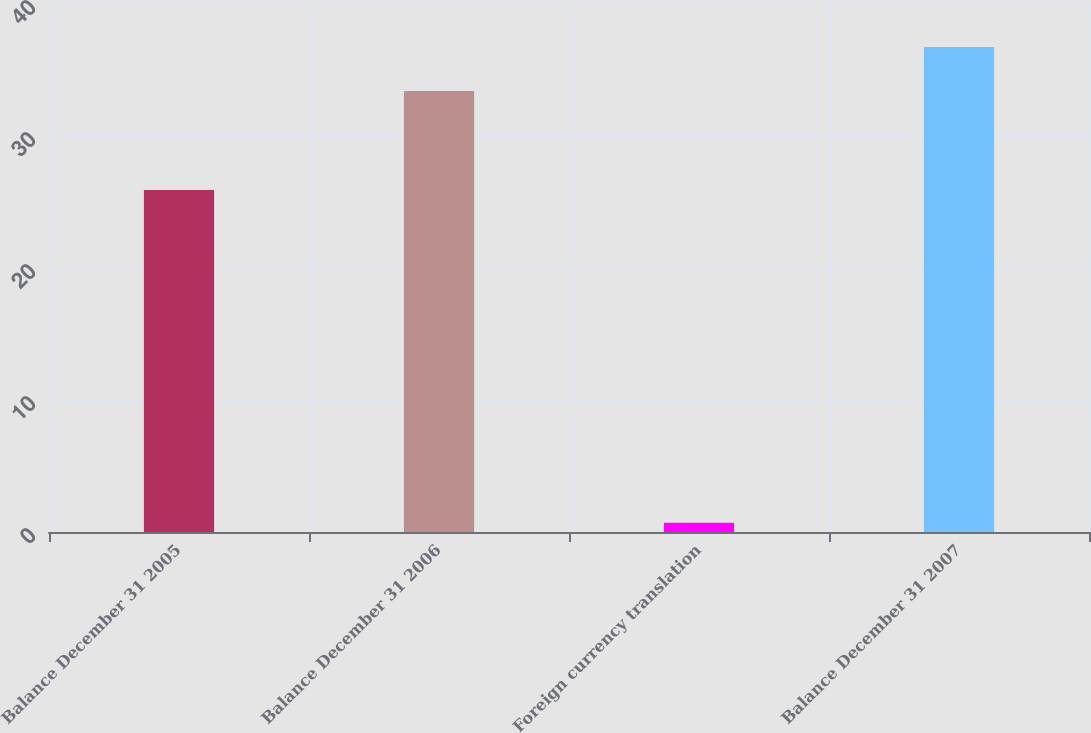Convert chart. <chart><loc_0><loc_0><loc_500><loc_500><bar_chart><fcel>Balance December 31 2005<fcel>Balance December 31 2006<fcel>Foreign currency translation<fcel>Balance December 31 2007<nl><fcel>25.9<fcel>33.4<fcel>0.7<fcel>36.74<nl></chart> 